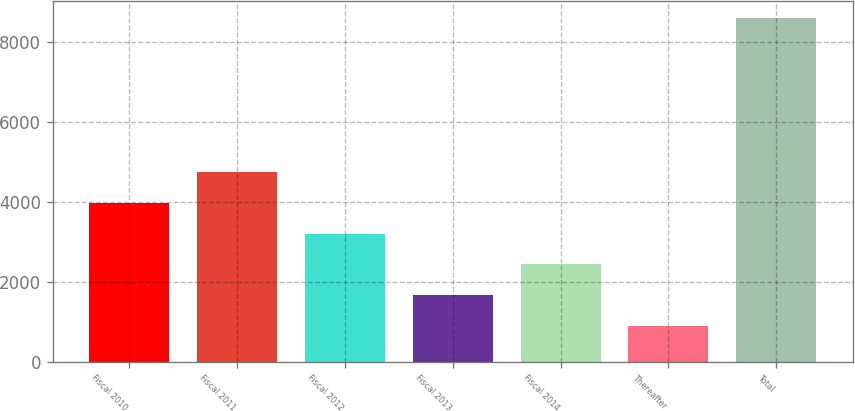Convert chart. <chart><loc_0><loc_0><loc_500><loc_500><bar_chart><fcel>Fiscal 2010<fcel>Fiscal 2011<fcel>Fiscal 2012<fcel>Fiscal 2013<fcel>Fiscal 2014<fcel>Thereafter<fcel>Total<nl><fcel>3975<fcel>4745.5<fcel>3204.5<fcel>1663.5<fcel>2434<fcel>893<fcel>8598<nl></chart> 